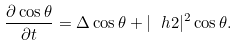<formula> <loc_0><loc_0><loc_500><loc_500>\frac { \partial \cos \theta } { \partial t } = \Delta \cos \theta + | \ h 2 | ^ { 2 } \cos \theta .</formula> 